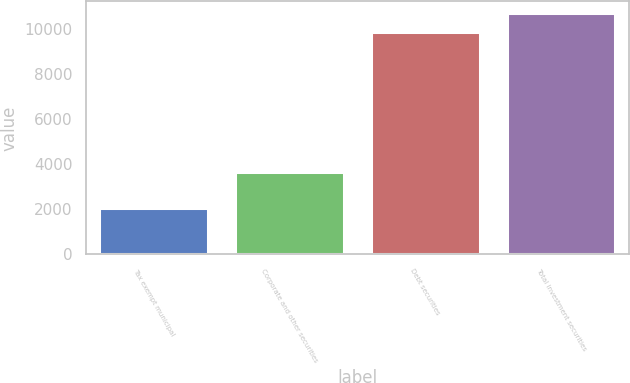Convert chart to OTSL. <chart><loc_0><loc_0><loc_500><loc_500><bar_chart><fcel>Tax exempt municipal<fcel>Corporate and other securities<fcel>Debt securities<fcel>Total investment securities<nl><fcel>2060<fcel>3678<fcel>9892<fcel>10703.7<nl></chart> 